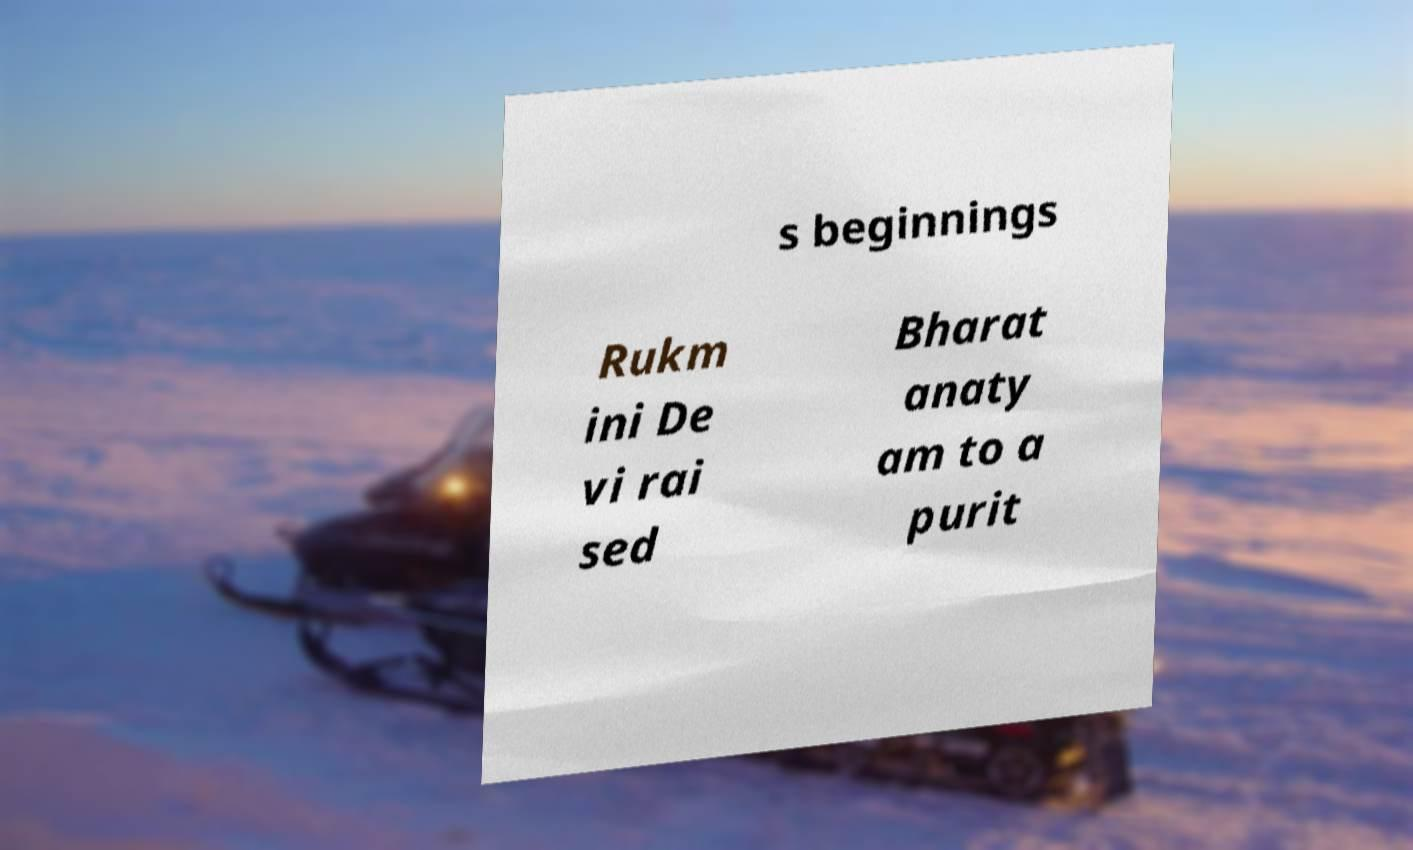Could you assist in decoding the text presented in this image and type it out clearly? s beginnings Rukm ini De vi rai sed Bharat anaty am to a purit 